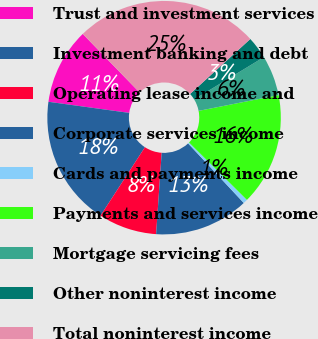<chart> <loc_0><loc_0><loc_500><loc_500><pie_chart><fcel>Trust and investment services<fcel>Investment banking and debt<fcel>Operating lease income and<fcel>Corporate services income<fcel>Cards and payments income<fcel>Payments and services income<fcel>Mortgage servicing fees<fcel>Other noninterest income<fcel>Total noninterest income<nl><fcel>10.56%<fcel>18.02%<fcel>8.07%<fcel>13.05%<fcel>0.6%<fcel>15.54%<fcel>5.58%<fcel>3.09%<fcel>25.49%<nl></chart> 